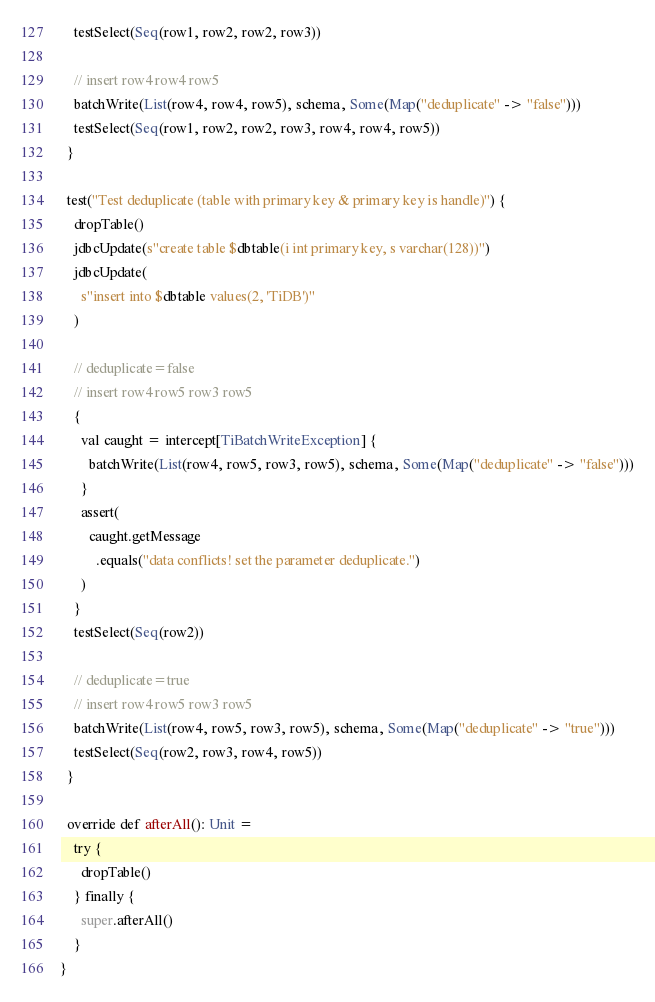Convert code to text. <code><loc_0><loc_0><loc_500><loc_500><_Scala_>    testSelect(Seq(row1, row2, row2, row3))

    // insert row4 row4 row5
    batchWrite(List(row4, row4, row5), schema, Some(Map("deduplicate" -> "false")))
    testSelect(Seq(row1, row2, row2, row3, row4, row4, row5))
  }

  test("Test deduplicate (table with primary key & primary key is handle)") {
    dropTable()
    jdbcUpdate(s"create table $dbtable(i int primary key, s varchar(128))")
    jdbcUpdate(
      s"insert into $dbtable values(2, 'TiDB')"
    )

    // deduplicate=false
    // insert row4 row5 row3 row5
    {
      val caught = intercept[TiBatchWriteException] {
        batchWrite(List(row4, row5, row3, row5), schema, Some(Map("deduplicate" -> "false")))
      }
      assert(
        caught.getMessage
          .equals("data conflicts! set the parameter deduplicate.")
      )
    }
    testSelect(Seq(row2))

    // deduplicate=true
    // insert row4 row5 row3 row5
    batchWrite(List(row4, row5, row3, row5), schema, Some(Map("deduplicate" -> "true")))
    testSelect(Seq(row2, row3, row4, row5))
  }

  override def afterAll(): Unit =
    try {
      dropTable()
    } finally {
      super.afterAll()
    }
}
</code> 